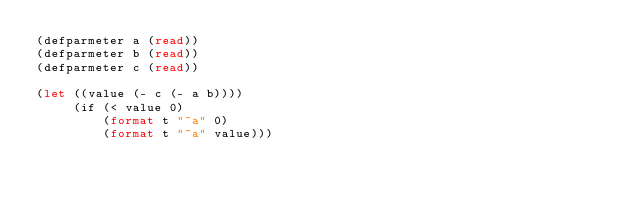<code> <loc_0><loc_0><loc_500><loc_500><_Lisp_>(defparmeter a (read))
(defparmeter b (read))
(defparmeter c (read))

(let ((value (- c (- a b))))
     (if (< value 0)
         (format t "~a" 0)
         (format t "~a" value)))</code> 